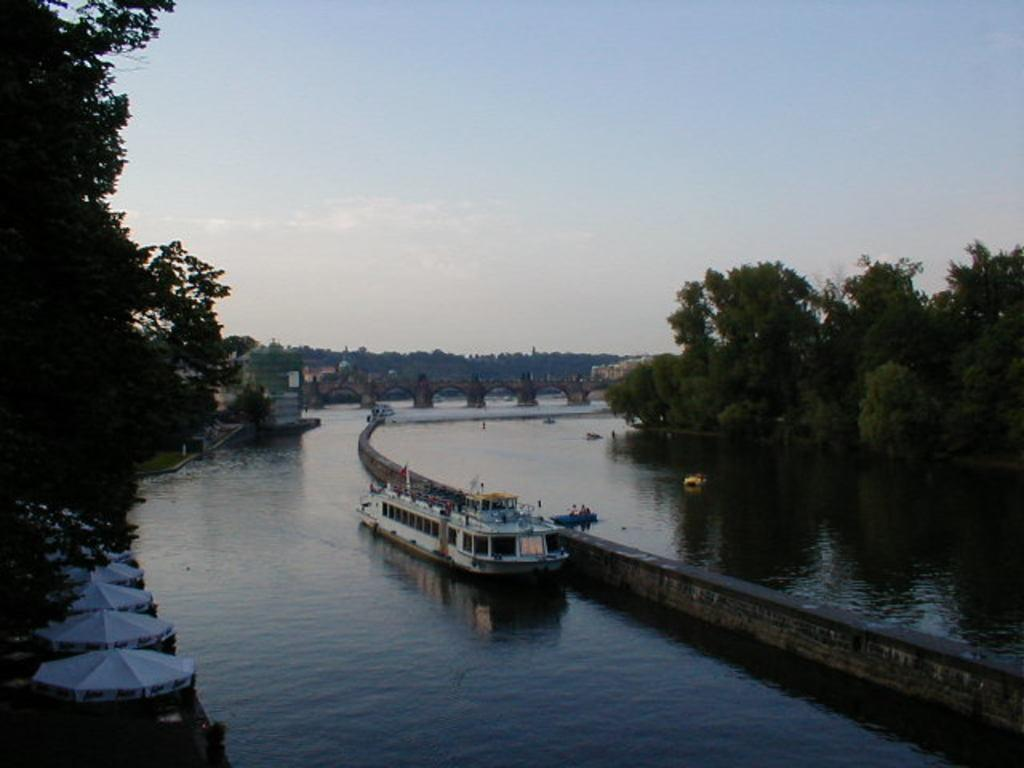What is the main subject of the image? The main subject of the image is a boat. What is the boat doing in the image? The boat is floating on water in the image. Where is the boat located in the image? The boat is in the middle of the image. What can be seen on either side of the boat? There are trees on either side of the river in the image. What is visible in the background of the image? The sky is visible in the background of the image. What type of plants can be seen growing in the boat's cellar in the image? There is no mention of a cellar or plants growing in the boat in the image. 